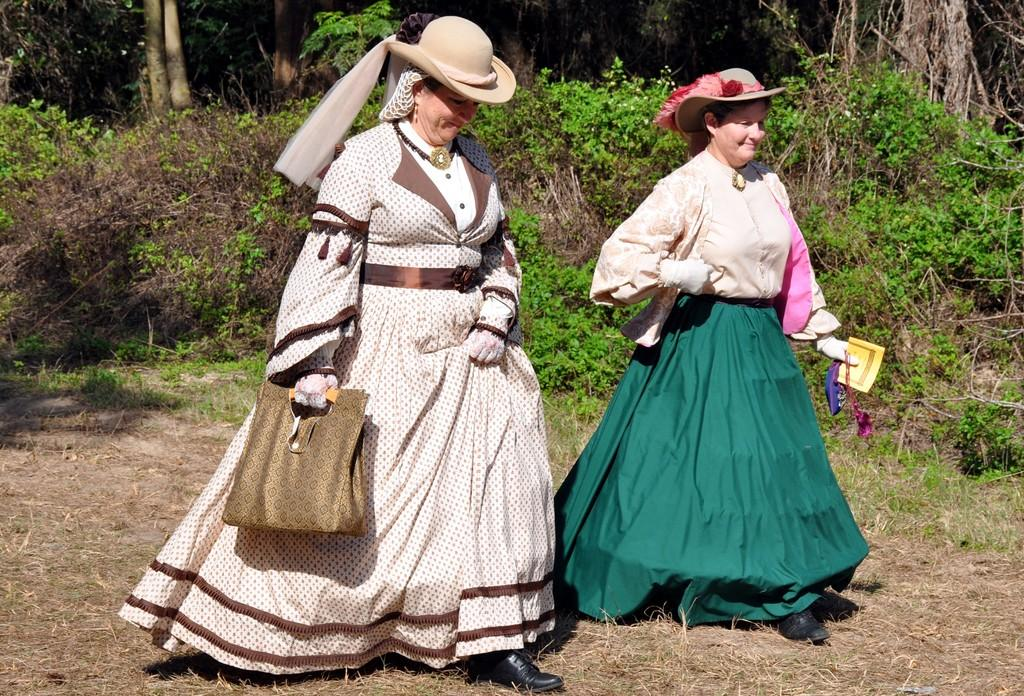How many people are in the image? There are two persons in the image. What are the persons wearing on their heads? The persons are wearing hats. What are the persons doing in the image? The persons are walking. What can be seen in the background of the image? There are plants in the background of the image. What type of brake can be seen on the train in the image? There is no train present in the image; it features two persons walking and plants in the background. Is the band playing music in the image? There is no band present in the image; it features two persons walking and plants in the background. 